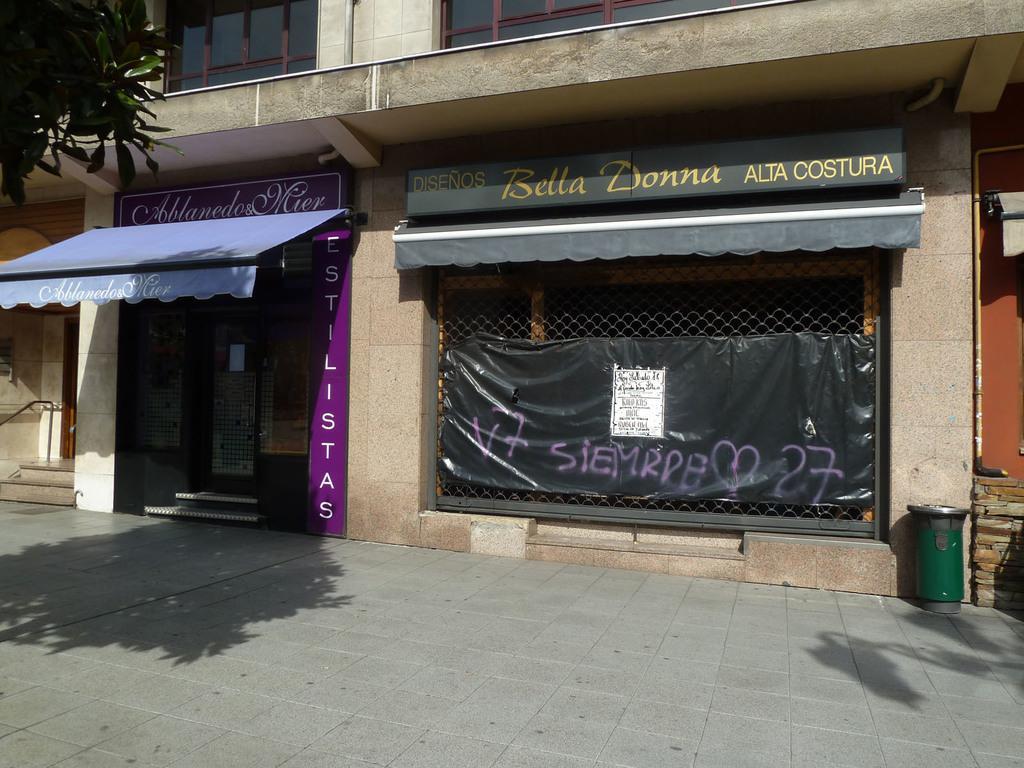Can you describe this image briefly? At the bottom I can see the floor and at the top there is a building. On the right side, I can see a green color dustbin which is placed on the floor. On the top left I can see the leaves of a tree. 